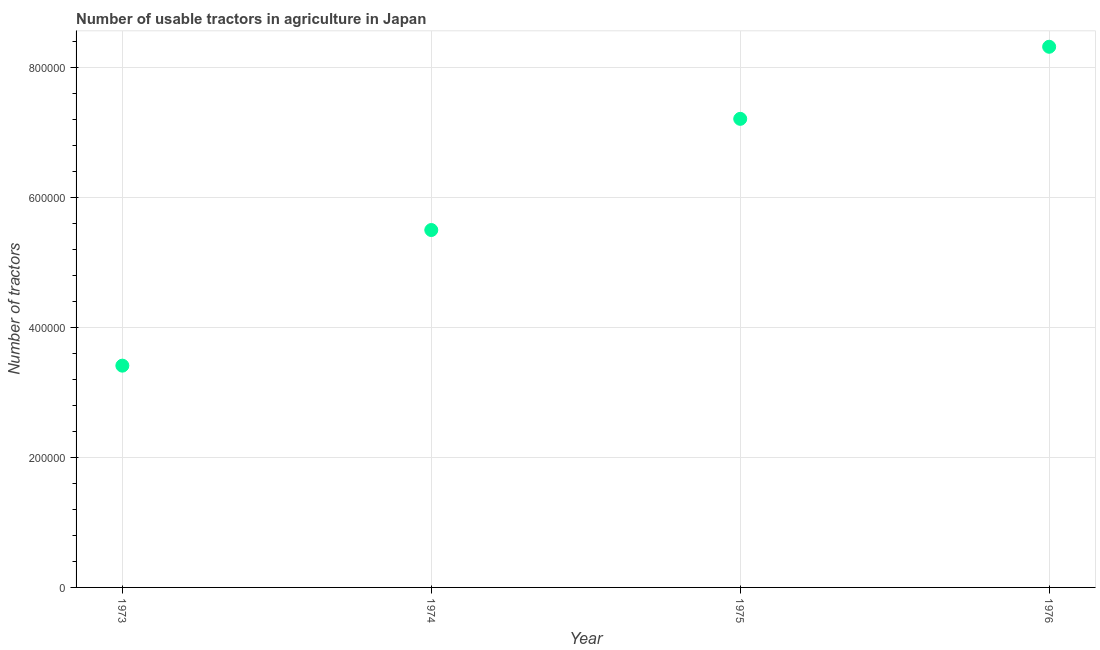What is the number of tractors in 1976?
Offer a very short reply. 8.32e+05. Across all years, what is the maximum number of tractors?
Keep it short and to the point. 8.32e+05. Across all years, what is the minimum number of tractors?
Keep it short and to the point. 3.41e+05. In which year was the number of tractors maximum?
Your answer should be very brief. 1976. What is the sum of the number of tractors?
Offer a terse response. 2.44e+06. What is the difference between the number of tractors in 1974 and 1976?
Ensure brevity in your answer.  -2.82e+05. What is the average number of tractors per year?
Offer a very short reply. 6.11e+05. What is the median number of tractors?
Provide a short and direct response. 6.36e+05. In how many years, is the number of tractors greater than 480000 ?
Your answer should be compact. 3. What is the ratio of the number of tractors in 1975 to that in 1976?
Your answer should be compact. 0.87. Is the number of tractors in 1974 less than that in 1976?
Provide a succinct answer. Yes. What is the difference between the highest and the second highest number of tractors?
Offer a terse response. 1.11e+05. What is the difference between the highest and the lowest number of tractors?
Offer a terse response. 4.91e+05. What is the difference between two consecutive major ticks on the Y-axis?
Your answer should be compact. 2.00e+05. Are the values on the major ticks of Y-axis written in scientific E-notation?
Offer a terse response. No. Does the graph contain any zero values?
Offer a very short reply. No. Does the graph contain grids?
Offer a very short reply. Yes. What is the title of the graph?
Provide a succinct answer. Number of usable tractors in agriculture in Japan. What is the label or title of the Y-axis?
Provide a short and direct response. Number of tractors. What is the Number of tractors in 1973?
Offer a very short reply. 3.41e+05. What is the Number of tractors in 1975?
Offer a very short reply. 7.21e+05. What is the Number of tractors in 1976?
Keep it short and to the point. 8.32e+05. What is the difference between the Number of tractors in 1973 and 1974?
Your response must be concise. -2.09e+05. What is the difference between the Number of tractors in 1973 and 1975?
Provide a succinct answer. -3.80e+05. What is the difference between the Number of tractors in 1973 and 1976?
Offer a terse response. -4.91e+05. What is the difference between the Number of tractors in 1974 and 1975?
Provide a short and direct response. -1.71e+05. What is the difference between the Number of tractors in 1974 and 1976?
Give a very brief answer. -2.82e+05. What is the difference between the Number of tractors in 1975 and 1976?
Ensure brevity in your answer.  -1.11e+05. What is the ratio of the Number of tractors in 1973 to that in 1974?
Ensure brevity in your answer.  0.62. What is the ratio of the Number of tractors in 1973 to that in 1975?
Offer a very short reply. 0.47. What is the ratio of the Number of tractors in 1973 to that in 1976?
Your answer should be compact. 0.41. What is the ratio of the Number of tractors in 1974 to that in 1975?
Provide a succinct answer. 0.76. What is the ratio of the Number of tractors in 1974 to that in 1976?
Offer a terse response. 0.66. What is the ratio of the Number of tractors in 1975 to that in 1976?
Make the answer very short. 0.87. 